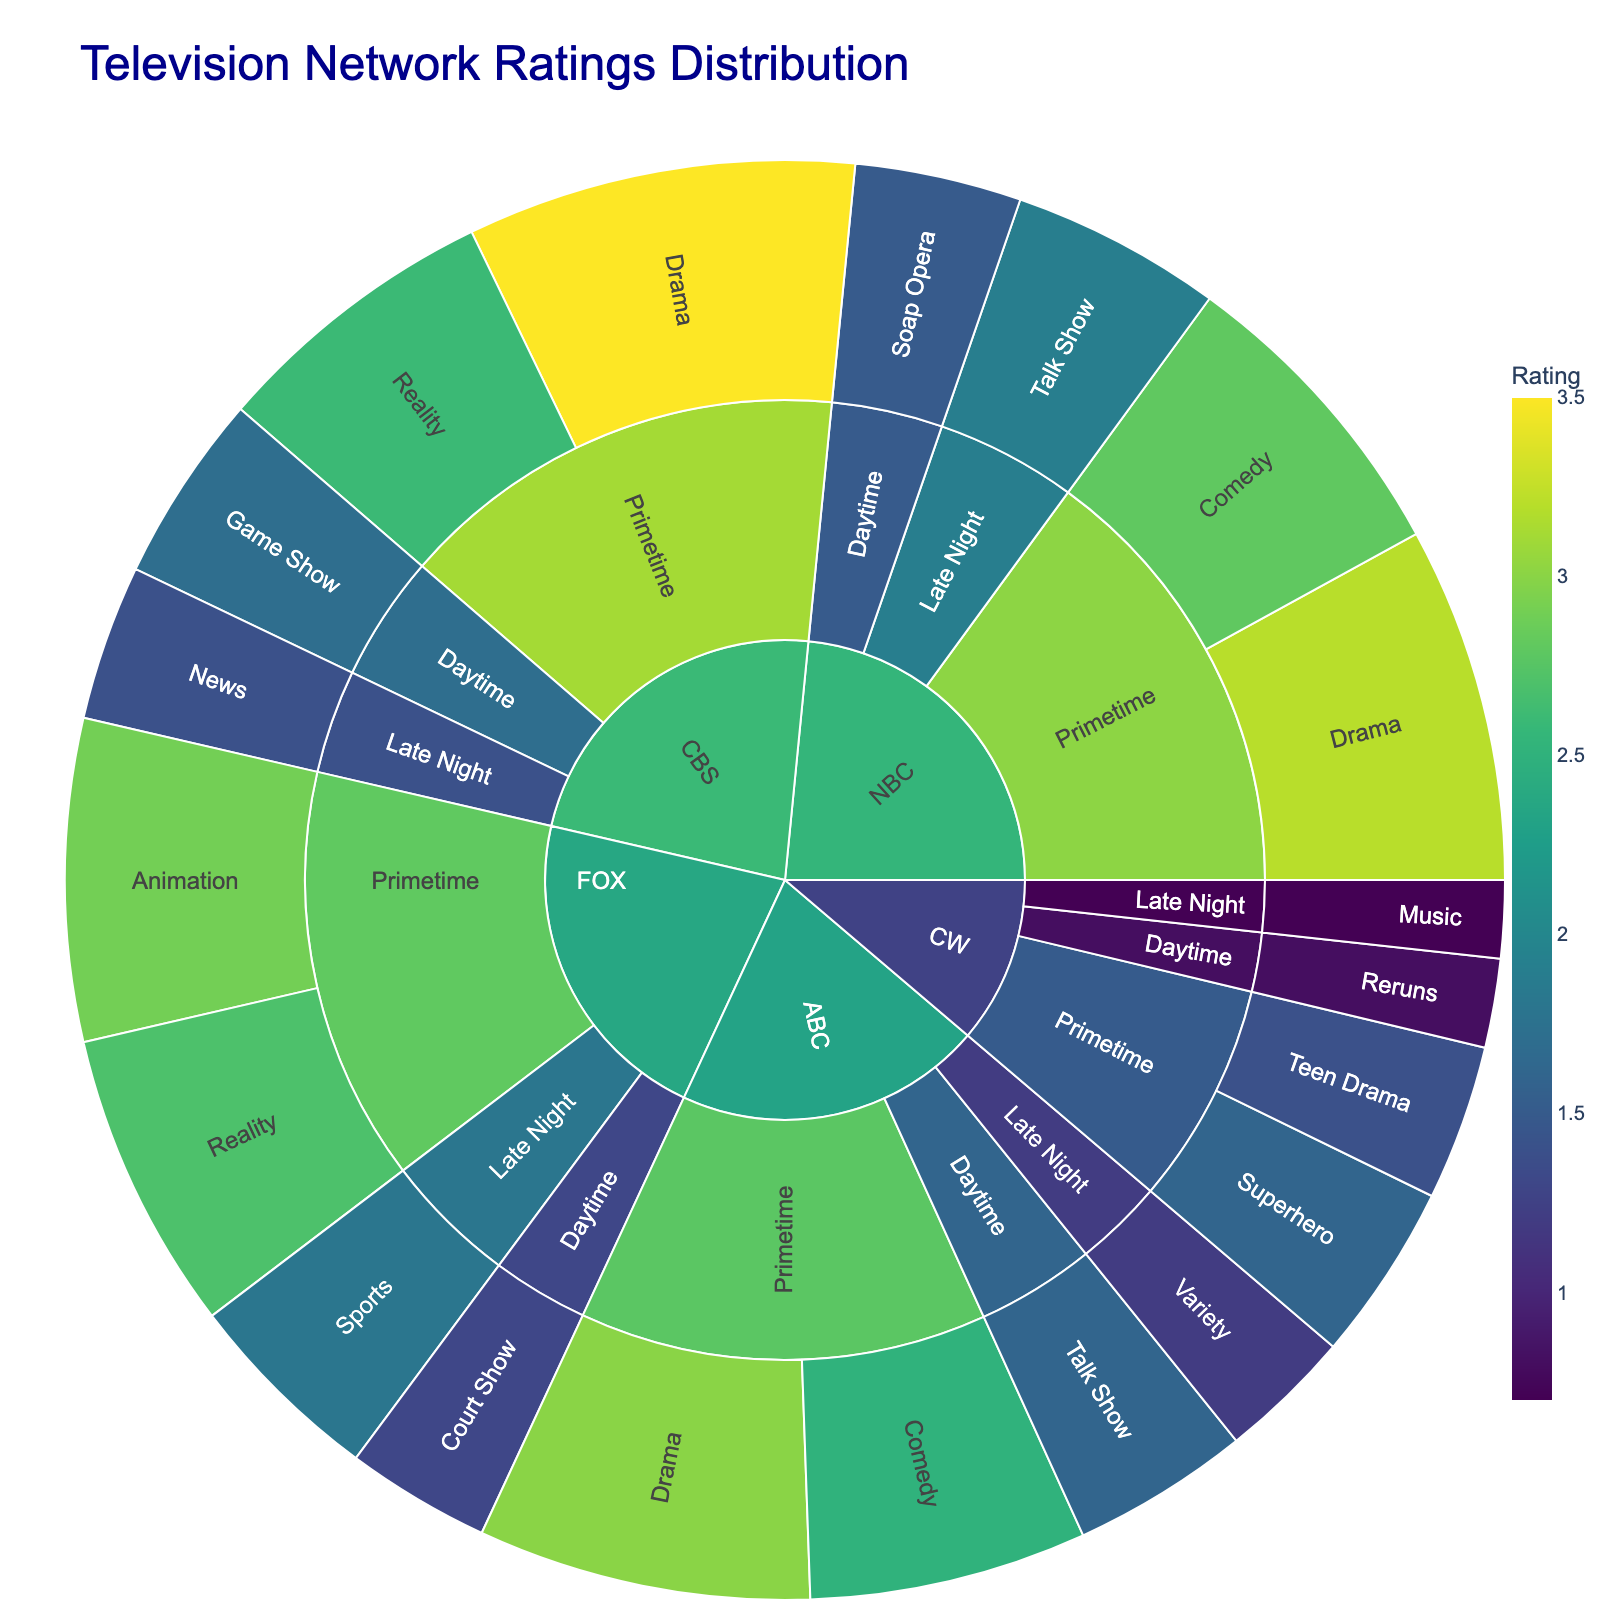what is the title of the plot? The title of the plot is typically positioned centrally at the top of the figure. In this case, the specified title in the code is "Television Network Ratings Distribution."
Answer: Television Network Ratings Distribution how many top-level categories are there? The top-level categories in a sunburst plot are usually the main segments radiating from the center. For this plot, the top-level categories correspond to the distinct networks: NBC, CBS, ABC, FOX, and CW. Counting these gives a total of 5.
Answer: 5 which network has the highest rating for Primetime Drama? First, look for the segments under the "Primetime" time slot for each network. Then, identify the "Drama" genres within those segments. The ratings are provided along with each genre. The Primetime Drama ratings are 3.2 for NBC, 3.5 for CBS, and 3.0 for ABC. CBS has the highest rating of 3.5.
Answer: CBS what's the combined rating for ABC in all Daytime genres? To find the total rating for ABC in the Daytime time slot, look at the "Daytime" segment for ABC and sum the ratings of all its genres. ABC has Talk Show with a rating of 1.6 in Daytime. Thus, the total rating is 1.6.
Answer: 1.6 how does the rating for FOX's Primetime Animation compare to that of its Reality genre? Identify the ratings for Animation and Reality under FOX's Primetime slot. Animation has a rating of 2.9, and Reality has a rating of 2.7. Comparing them, Animation has a higher rating than Reality.
Answer: Animation is higher across all networks, which timeslot has the highest individual rating? Examine the highest ratings for each time slot across all networks. The highest individual ratings are: Primetime - 3.5 (CBS Drama), Daytime - 1.7 (CBS Game Show), Late Night - 1.9 (NBC Talk Show). The highest rating overall is 3.5 in Primetime.
Answer: Primetime what is the average rating of CBS's Late Night programs? Find the ratings for CBS's Late Night programs: News has a rating of 1.4. Since there's only one program, the average is simply 1.4
Answer: 1.4 which genre has the lowest rating on CW during Late Night? Look under CW's Late Night segment and identify the genres and their ratings. The genres are Music with a rating of 0.7. Thus, Music has the lowest rating.
Answer: Music which genre appears the most frequently across all networks in Primetime? Scan through all Primetime segments across networks and count the occurrences of each genre. Drama appears for NBC, CBS, and ABC. The other genres do not appear as frequently. Therefore, Drama appears the most frequently.
Answer: Drama 